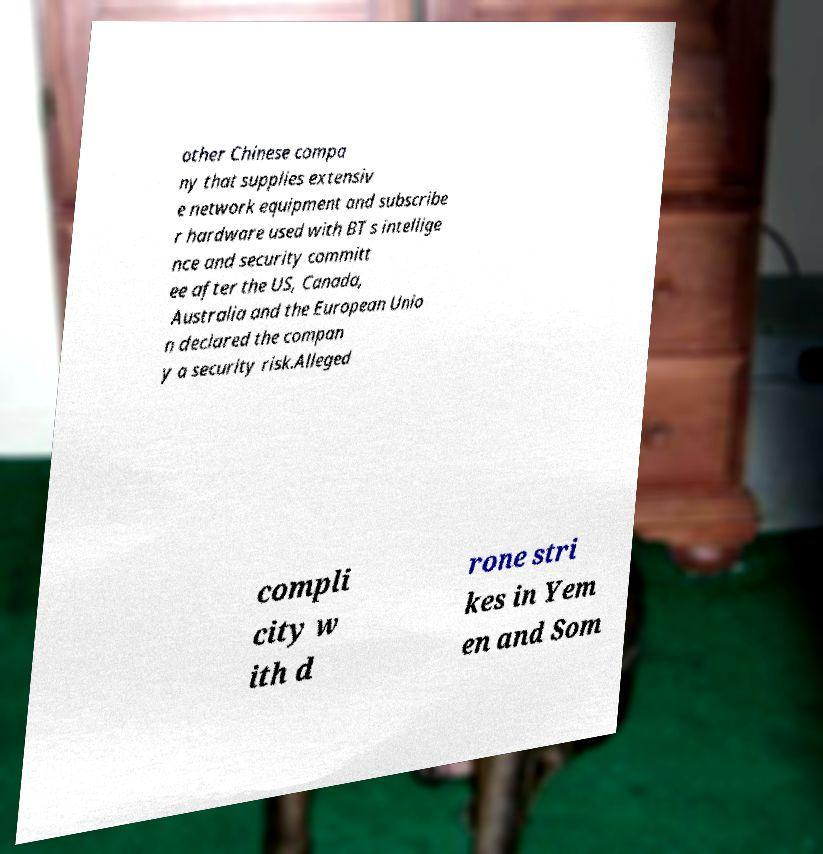For documentation purposes, I need the text within this image transcribed. Could you provide that? other Chinese compa ny that supplies extensiv e network equipment and subscribe r hardware used with BT s intellige nce and security committ ee after the US, Canada, Australia and the European Unio n declared the compan y a security risk.Alleged compli city w ith d rone stri kes in Yem en and Som 